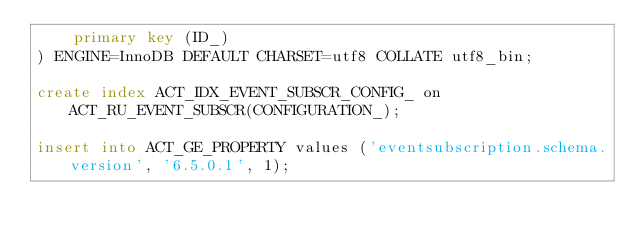Convert code to text. <code><loc_0><loc_0><loc_500><loc_500><_SQL_>    primary key (ID_)
) ENGINE=InnoDB DEFAULT CHARSET=utf8 COLLATE utf8_bin;

create index ACT_IDX_EVENT_SUBSCR_CONFIG_ on ACT_RU_EVENT_SUBSCR(CONFIGURATION_);

insert into ACT_GE_PROPERTY values ('eventsubscription.schema.version', '6.5.0.1', 1);</code> 